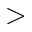Convert formula to latex. <formula><loc_0><loc_0><loc_500><loc_500>></formula> 